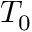Convert formula to latex. <formula><loc_0><loc_0><loc_500><loc_500>T _ { 0 }</formula> 